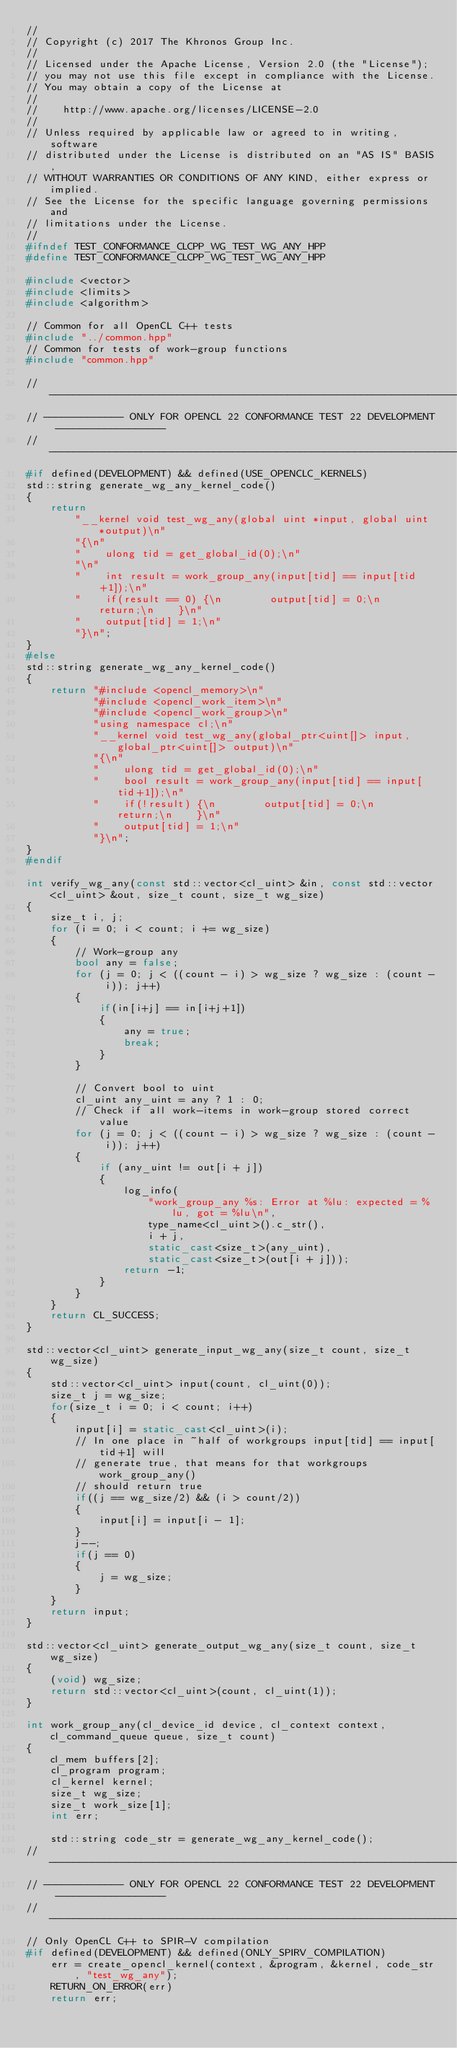<code> <loc_0><loc_0><loc_500><loc_500><_C++_>//
// Copyright (c) 2017 The Khronos Group Inc.
// 
// Licensed under the Apache License, Version 2.0 (the "License");
// you may not use this file except in compliance with the License.
// You may obtain a copy of the License at
//
//    http://www.apache.org/licenses/LICENSE-2.0
//
// Unless required by applicable law or agreed to in writing, software
// distributed under the License is distributed on an "AS IS" BASIS,
// WITHOUT WARRANTIES OR CONDITIONS OF ANY KIND, either express or implied.
// See the License for the specific language governing permissions and
// limitations under the License.
//
#ifndef TEST_CONFORMANCE_CLCPP_WG_TEST_WG_ANY_HPP
#define TEST_CONFORMANCE_CLCPP_WG_TEST_WG_ANY_HPP

#include <vector>
#include <limits>
#include <algorithm>

// Common for all OpenCL C++ tests
#include "../common.hpp"
// Common for tests of work-group functions
#include "common.hpp"

// -----------------------------------------------------------------------------------
// ------------- ONLY FOR OPENCL 22 CONFORMANCE TEST 22 DEVELOPMENT ------------------
// -----------------------------------------------------------------------------------
#if defined(DEVELOPMENT) && defined(USE_OPENCLC_KERNELS)
std::string generate_wg_any_kernel_code()
{
    return
        "__kernel void test_wg_any(global uint *input, global uint *output)\n"
        "{\n"
        "    ulong tid = get_global_id(0);\n"
        "\n"
        "    int result = work_group_any(input[tid] == input[tid+1]);\n"
        "    if(result == 0) {\n        output[tid] = 0;\n        return;\n    }\n"
        "    output[tid] = 1;\n"
        "}\n";
}
#else
std::string generate_wg_any_kernel_code()
{
    return "#include <opencl_memory>\n"
           "#include <opencl_work_item>\n"
           "#include <opencl_work_group>\n"
           "using namespace cl;\n"
           "__kernel void test_wg_any(global_ptr<uint[]> input, global_ptr<uint[]> output)\n"
           "{\n"
           "    ulong tid = get_global_id(0);\n"
           "    bool result = work_group_any(input[tid] == input[tid+1]);\n"
           "    if(!result) {\n        output[tid] = 0;\n        return;\n    }\n"
           "    output[tid] = 1;\n"
           "}\n";
}
#endif

int verify_wg_any(const std::vector<cl_uint> &in, const std::vector<cl_uint> &out, size_t count, size_t wg_size)
{
    size_t i, j;
    for (i = 0; i < count; i += wg_size)
    {
        // Work-group any
        bool any = false;
        for (j = 0; j < ((count - i) > wg_size ? wg_size : (count - i)); j++)
        {
            if(in[i+j] == in[i+j+1])
            {
                any = true;
                break;
            }
        }

        // Convert bool to uint
        cl_uint any_uint = any ? 1 : 0;
        // Check if all work-items in work-group stored correct value
        for (j = 0; j < ((count - i) > wg_size ? wg_size : (count - i)); j++)
        {
            if (any_uint != out[i + j])
            {
                log_info(
                    "work_group_any %s: Error at %lu: expected = %lu, got = %lu\n",
                    type_name<cl_uint>().c_str(),
                    i + j,
                    static_cast<size_t>(any_uint),
                    static_cast<size_t>(out[i + j]));
                return -1;
            }
        }
    }
    return CL_SUCCESS;
}

std::vector<cl_uint> generate_input_wg_any(size_t count, size_t wg_size)
{
    std::vector<cl_uint> input(count, cl_uint(0));
    size_t j = wg_size;
    for(size_t i = 0; i < count; i++)
    {
        input[i] = static_cast<cl_uint>(i);
        // In one place in ~half of workgroups input[tid] == input[tid+1] will
        // generate true, that means for that workgroups work_group_any()
        // should return true
        if((j == wg_size/2) && (i > count/2))
        {
            input[i] = input[i - 1];
        }
        j--;
        if(j == 0)
        {
            j = wg_size;
        }
    }
    return input;
}

std::vector<cl_uint> generate_output_wg_any(size_t count, size_t wg_size)
{
    (void) wg_size;
    return std::vector<cl_uint>(count, cl_uint(1));
}

int work_group_any(cl_device_id device, cl_context context, cl_command_queue queue, size_t count)
{
    cl_mem buffers[2];
    cl_program program;
    cl_kernel kernel;
    size_t wg_size;
    size_t work_size[1];
    int err;

    std::string code_str = generate_wg_any_kernel_code();
// -----------------------------------------------------------------------------------
// ------------- ONLY FOR OPENCL 22 CONFORMANCE TEST 22 DEVELOPMENT ------------------
// -----------------------------------------------------------------------------------
// Only OpenCL C++ to SPIR-V compilation
#if defined(DEVELOPMENT) && defined(ONLY_SPIRV_COMPILATION)
    err = create_opencl_kernel(context, &program, &kernel, code_str, "test_wg_any");
    RETURN_ON_ERROR(err)
    return err;</code> 